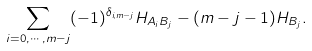Convert formula to latex. <formula><loc_0><loc_0><loc_500><loc_500>\sum _ { i = 0 , \cdots , m - j } ( - 1 ) ^ { \delta _ { i , m - j } } H _ { A _ { i } B _ { j } } - ( m - j - 1 ) H _ { B _ { j } } .</formula> 